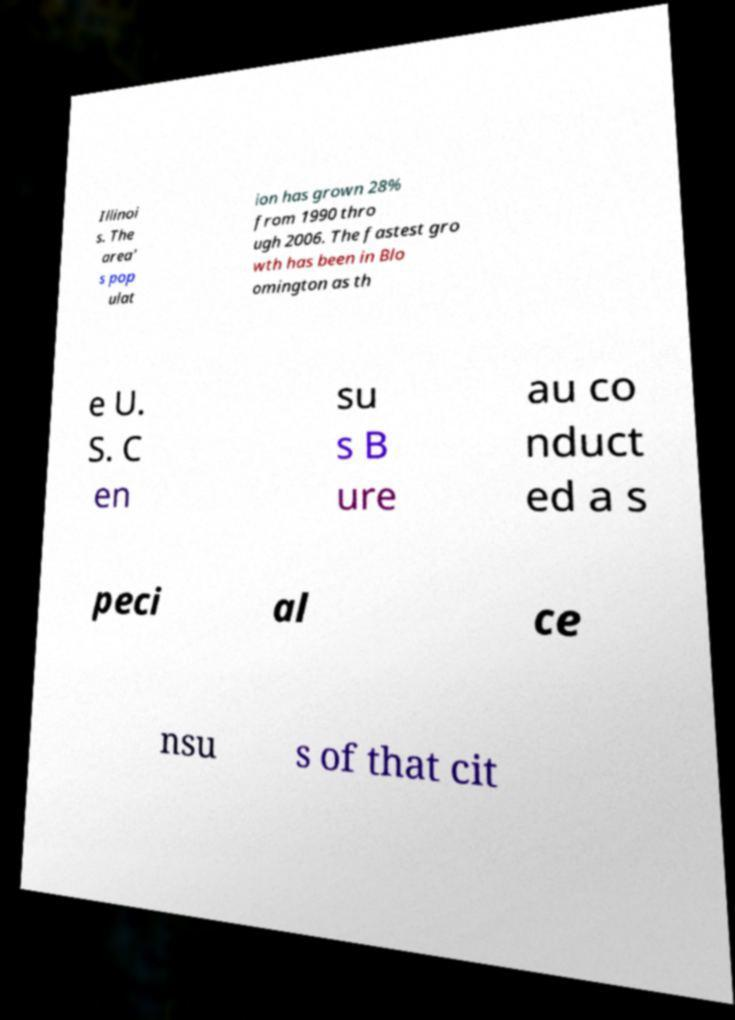Please identify and transcribe the text found in this image. Illinoi s. The area' s pop ulat ion has grown 28% from 1990 thro ugh 2006. The fastest gro wth has been in Blo omington as th e U. S. C en su s B ure au co nduct ed a s peci al ce nsu s of that cit 